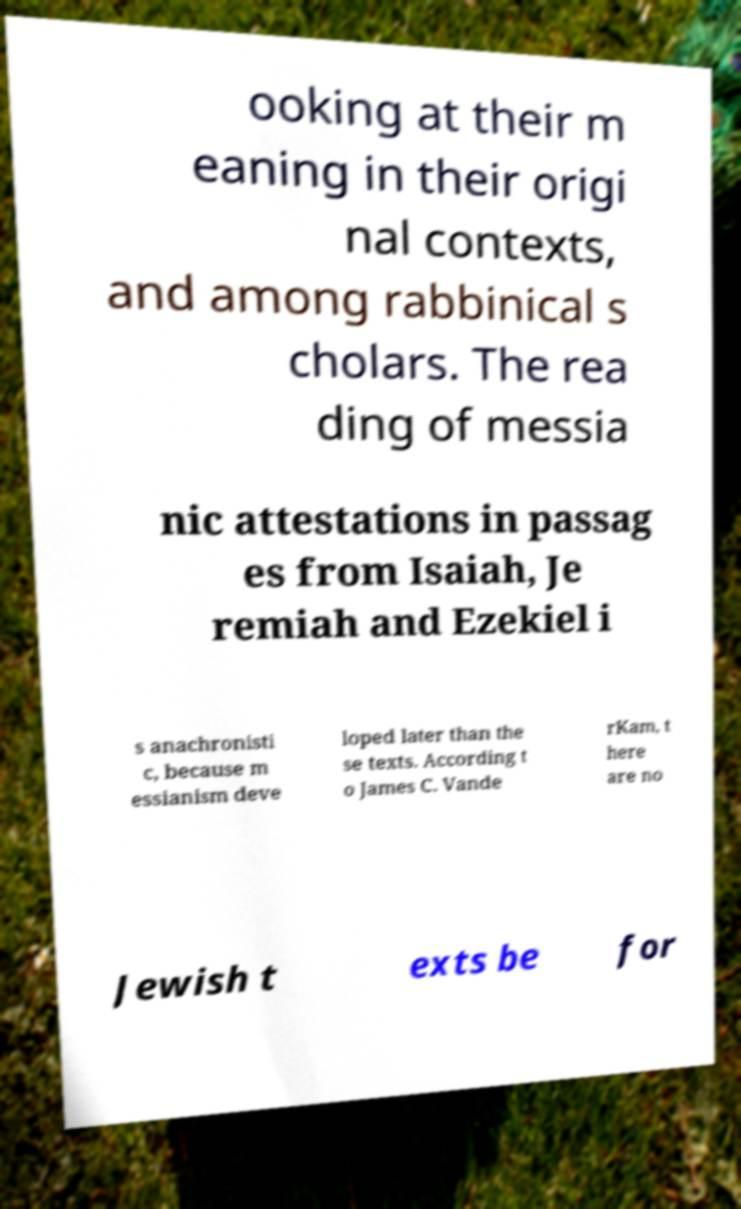I need the written content from this picture converted into text. Can you do that? ooking at their m eaning in their origi nal contexts, and among rabbinical s cholars. The rea ding of messia nic attestations in passag es from Isaiah, Je remiah and Ezekiel i s anachronisti c, because m essianism deve loped later than the se texts. According t o James C. Vande rKam, t here are no Jewish t exts be for 